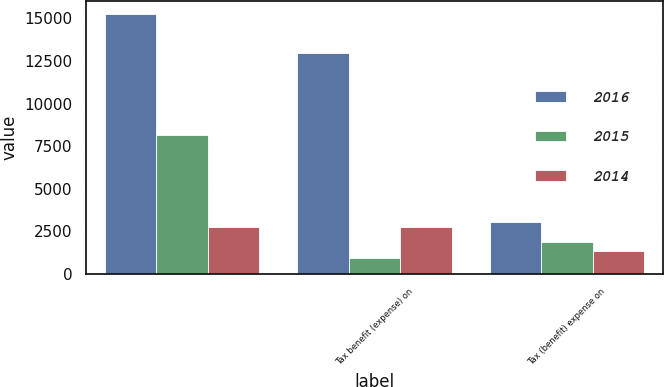Convert chart. <chart><loc_0><loc_0><loc_500><loc_500><stacked_bar_chart><ecel><fcel>Unnamed: 1<fcel>Tax benefit (expense) on<fcel>Tax (benefit) expense on<nl><fcel>2016<fcel>15251<fcel>12945<fcel>3038<nl><fcel>2015<fcel>8180<fcel>928<fcel>1861<nl><fcel>2014<fcel>2763<fcel>2763<fcel>1327<nl></chart> 